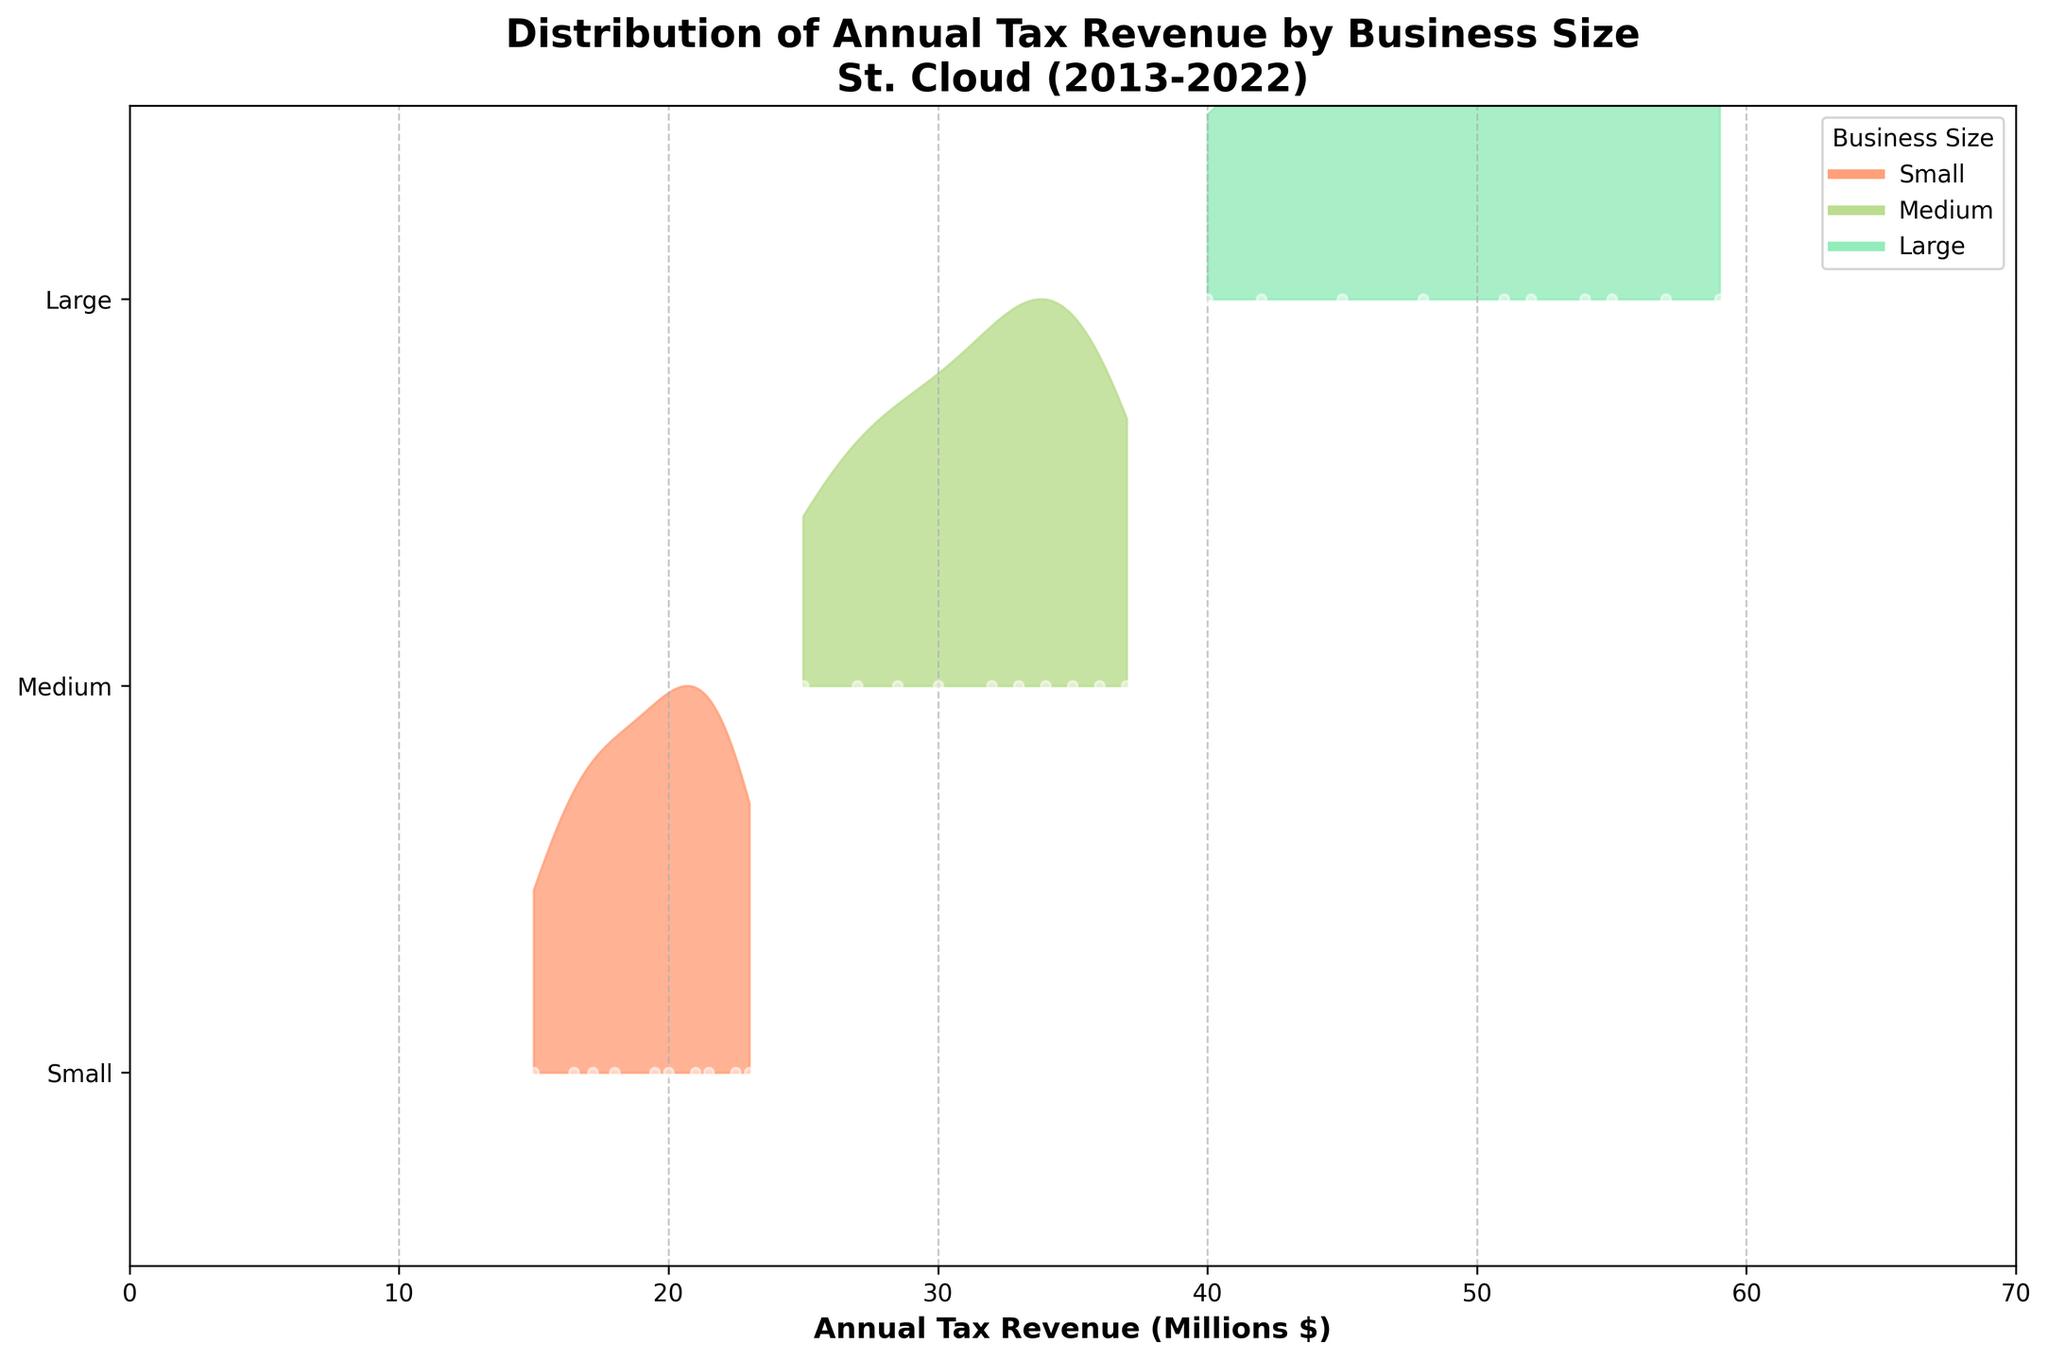What is the title of the figure? The title can often be found at the top of the figure. In this case, it reads "Distribution of Annual Tax Revenue by Business Size\nSt. Cloud (2013-2022)".
Answer: Distribution of Annual Tax Revenue by Business Size\nSt. Cloud (2013-2022) Which business size has the highest annual tax revenue distribution in 2022? By examining the plot, the "Large" businesses have the highest tax revenue distribution in 2022, as indicated by the peak at the rightmost end of the ridgeline for Large businesses.
Answer: Large How does the 2020 tax revenue distribution for Medium businesses compare to that in 2021? One can compare the position of the peaks for Medium businesses in 2020 and 2021. The 2020 peak is at approximately $33M, while the 2021 peak is at about $35M, indicating an increase in revenue from 2020 to 2021.
Answer: 2021 has higher revenue What is the range of annual tax revenues (in millions) for Small businesses in the given period? By observing the spread of Small businesses' ridgeline plot, it starts around $15M in 2013 and grows to around $23M by 2022. This represents the range of annual tax revenues for Small businesses over the decade.
Answer: $15M to $23M Which year shows a noticeable decrease in annual tax revenue for Small businesses compared to the previous year? By analyzing the plot for Small businesses, 2020 shows a dip compared to 2019, dropping from approximately $22.5M to $20M.
Answer: 2020 Between 2017 and 2018, did the Large businesses' tax revenue distribution increase, decrease, or stay the same? The ridgeline plot shows that the peak for Large businesses moves from around $51M in 2017 to around $54M in 2018, indicating an increase in revenue.
Answer: Increase What is the approximate difference in annual tax revenue between Medium and Large businesses in 2014? In 2014, Medium businesses had a revenue of about $27M, whereas Large businesses had around $42M. The difference is $15M.
Answer: $15M Which business size shows the most consistent annual tax revenue growth over the decade? By reviewing the ridgeline plot, Large businesses show a steady increase each year without dramatic fluctuations, indicating the most consistent growth.
Answer: Large What is the approximate average tax revenue for Small businesses from 2013 to 2022? The tax revenues for Small businesses over the years are approximately 15M (2013), 16.5M (2014), 17.2M (2015), 18M (2016), 19.5M (2017), 21M (2018), 22.5M (2019), 20M (2020), 21.5M (2021), and 23M (2022). Summing these and dividing by 10 yields an average: (15 + 16.5 + 17.2 + 18 + 19.5 + 21 + 22.5 + 20 + 21.5 + 23)/10 ≈ 19.42M.
Answer: 19.42M 